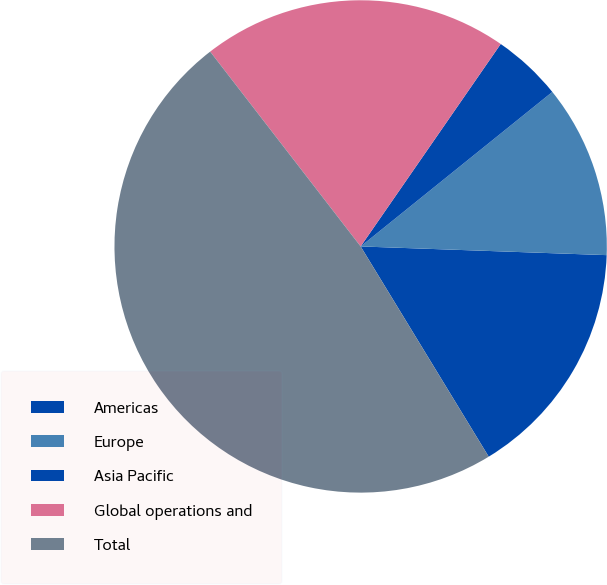Convert chart. <chart><loc_0><loc_0><loc_500><loc_500><pie_chart><fcel>Americas<fcel>Europe<fcel>Asia Pacific<fcel>Global operations and<fcel>Total<nl><fcel>15.73%<fcel>11.36%<fcel>4.57%<fcel>20.1%<fcel>48.24%<nl></chart> 